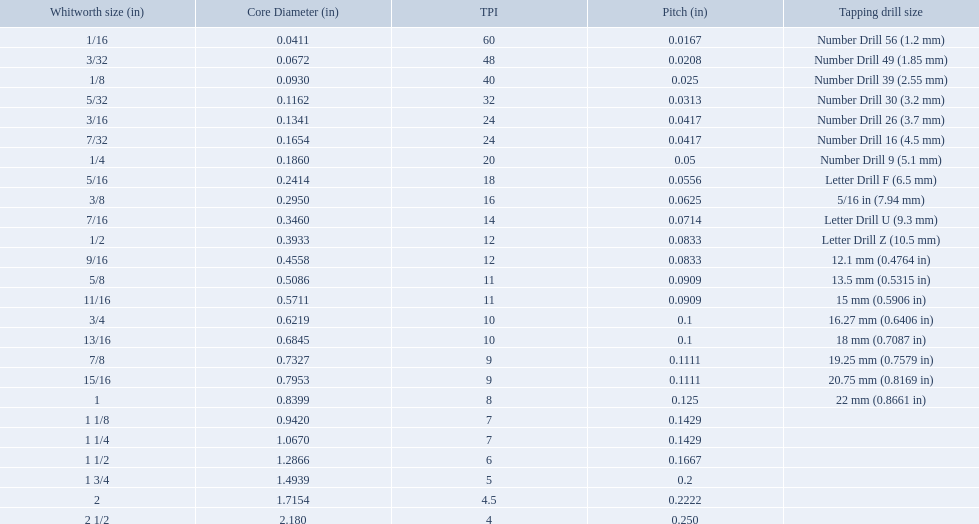What are the standard whitworth sizes in inches? 1/16, 3/32, 1/8, 5/32, 3/16, 7/32, 1/4, 5/16, 3/8, 7/16, 1/2, 9/16, 5/8, 11/16, 3/4, 13/16, 7/8, 15/16, 1, 1 1/8, 1 1/4, 1 1/2, 1 3/4, 2, 2 1/2. How many threads per inch does the 3/16 size have? 24. Which size (in inches) has the same number of threads? 7/32. What are the whitworth sizes? 1/16, 3/32, 1/8, 5/32, 3/16, 7/32, 1/4, 5/16, 3/8, 7/16, 1/2, 9/16, 5/8, 11/16, 3/4, 13/16, 7/8, 15/16, 1, 1 1/8, 1 1/4, 1 1/2, 1 3/4, 2, 2 1/2. And their threads per inch? 60, 48, 40, 32, 24, 24, 20, 18, 16, 14, 12, 12, 11, 11, 10, 10, 9, 9, 8, 7, 7, 6, 5, 4.5, 4. Now, which whitworth size has a thread-per-inch size of 5?? 1 3/4. What are all the whitworth sizes? 1/16, 3/32, 1/8, 5/32, 3/16, 7/32, 1/4, 5/16, 3/8, 7/16, 1/2, 9/16, 5/8, 11/16, 3/4, 13/16, 7/8, 15/16, 1, 1 1/8, 1 1/4, 1 1/2, 1 3/4, 2, 2 1/2. What are the threads per inch of these sizes? 60, 48, 40, 32, 24, 24, 20, 18, 16, 14, 12, 12, 11, 11, 10, 10, 9, 9, 8, 7, 7, 6, 5, 4.5, 4. Can you give me this table as a dict? {'header': ['Whitworth size (in)', 'Core Diameter (in)', 'TPI', 'Pitch (in)', 'Tapping drill size'], 'rows': [['1/16', '0.0411', '60', '0.0167', 'Number Drill 56 (1.2\xa0mm)'], ['3/32', '0.0672', '48', '0.0208', 'Number Drill 49 (1.85\xa0mm)'], ['1/8', '0.0930', '40', '0.025', 'Number Drill 39 (2.55\xa0mm)'], ['5/32', '0.1162', '32', '0.0313', 'Number Drill 30 (3.2\xa0mm)'], ['3/16', '0.1341', '24', '0.0417', 'Number Drill 26 (3.7\xa0mm)'], ['7/32', '0.1654', '24', '0.0417', 'Number Drill 16 (4.5\xa0mm)'], ['1/4', '0.1860', '20', '0.05', 'Number Drill 9 (5.1\xa0mm)'], ['5/16', '0.2414', '18', '0.0556', 'Letter Drill F (6.5\xa0mm)'], ['3/8', '0.2950', '16', '0.0625', '5/16\xa0in (7.94\xa0mm)'], ['7/16', '0.3460', '14', '0.0714', 'Letter Drill U (9.3\xa0mm)'], ['1/2', '0.3933', '12', '0.0833', 'Letter Drill Z (10.5\xa0mm)'], ['9/16', '0.4558', '12', '0.0833', '12.1\xa0mm (0.4764\xa0in)'], ['5/8', '0.5086', '11', '0.0909', '13.5\xa0mm (0.5315\xa0in)'], ['11/16', '0.5711', '11', '0.0909', '15\xa0mm (0.5906\xa0in)'], ['3/4', '0.6219', '10', '0.1', '16.27\xa0mm (0.6406\xa0in)'], ['13/16', '0.6845', '10', '0.1', '18\xa0mm (0.7087\xa0in)'], ['7/8', '0.7327', '9', '0.1111', '19.25\xa0mm (0.7579\xa0in)'], ['15/16', '0.7953', '9', '0.1111', '20.75\xa0mm (0.8169\xa0in)'], ['1', '0.8399', '8', '0.125', '22\xa0mm (0.8661\xa0in)'], ['1 1/8', '0.9420', '7', '0.1429', ''], ['1 1/4', '1.0670', '7', '0.1429', ''], ['1 1/2', '1.2866', '6', '0.1667', ''], ['1 3/4', '1.4939', '5', '0.2', ''], ['2', '1.7154', '4.5', '0.2222', ''], ['2 1/2', '2.180', '4', '0.250', '']]} Of these, which are 5? 5. What whitworth size has this threads per inch? 1 3/4. What is the core diameter for the number drill 26? 0.1341. What is the whitworth size (in) for this core diameter? 3/16. 